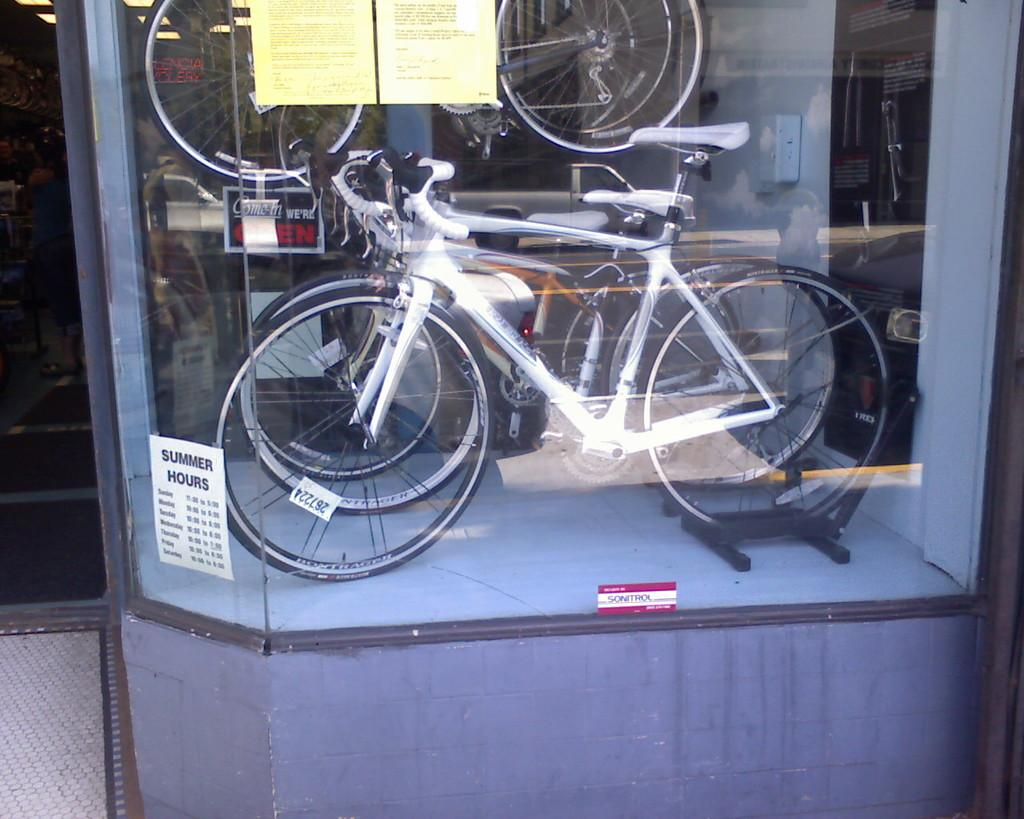What type of vehicles are in the image? There are bicycles in the image. Where are the bicycles located? The bicycles are placed in a showcase. What material covers the showcase? The showcase is covered with glass. What type of metal is used to create the prose in the image? There is no metal or prose present in the image; it features bicycles in a glass-covered showcase. 